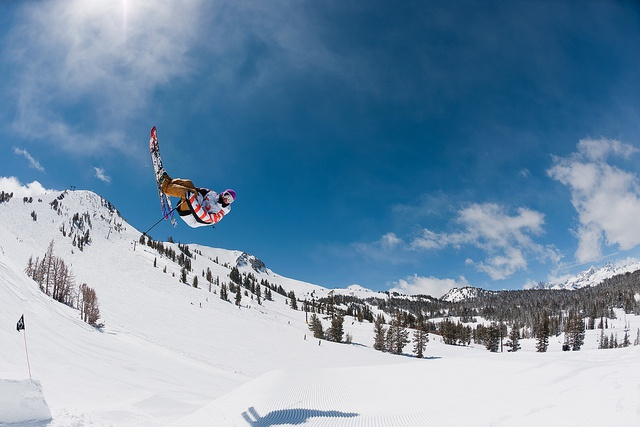Describe the objects in this image and their specific colors. I can see people in blue, black, lightgray, darkgray, and maroon tones and skis in blue, darkgray, and gray tones in this image. 